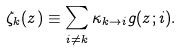Convert formula to latex. <formula><loc_0><loc_0><loc_500><loc_500>\zeta _ { k } ( z ) \equiv \sum _ { i \neq k } \kappa _ { k \rightarrow i } g ( z ; i ) .</formula> 